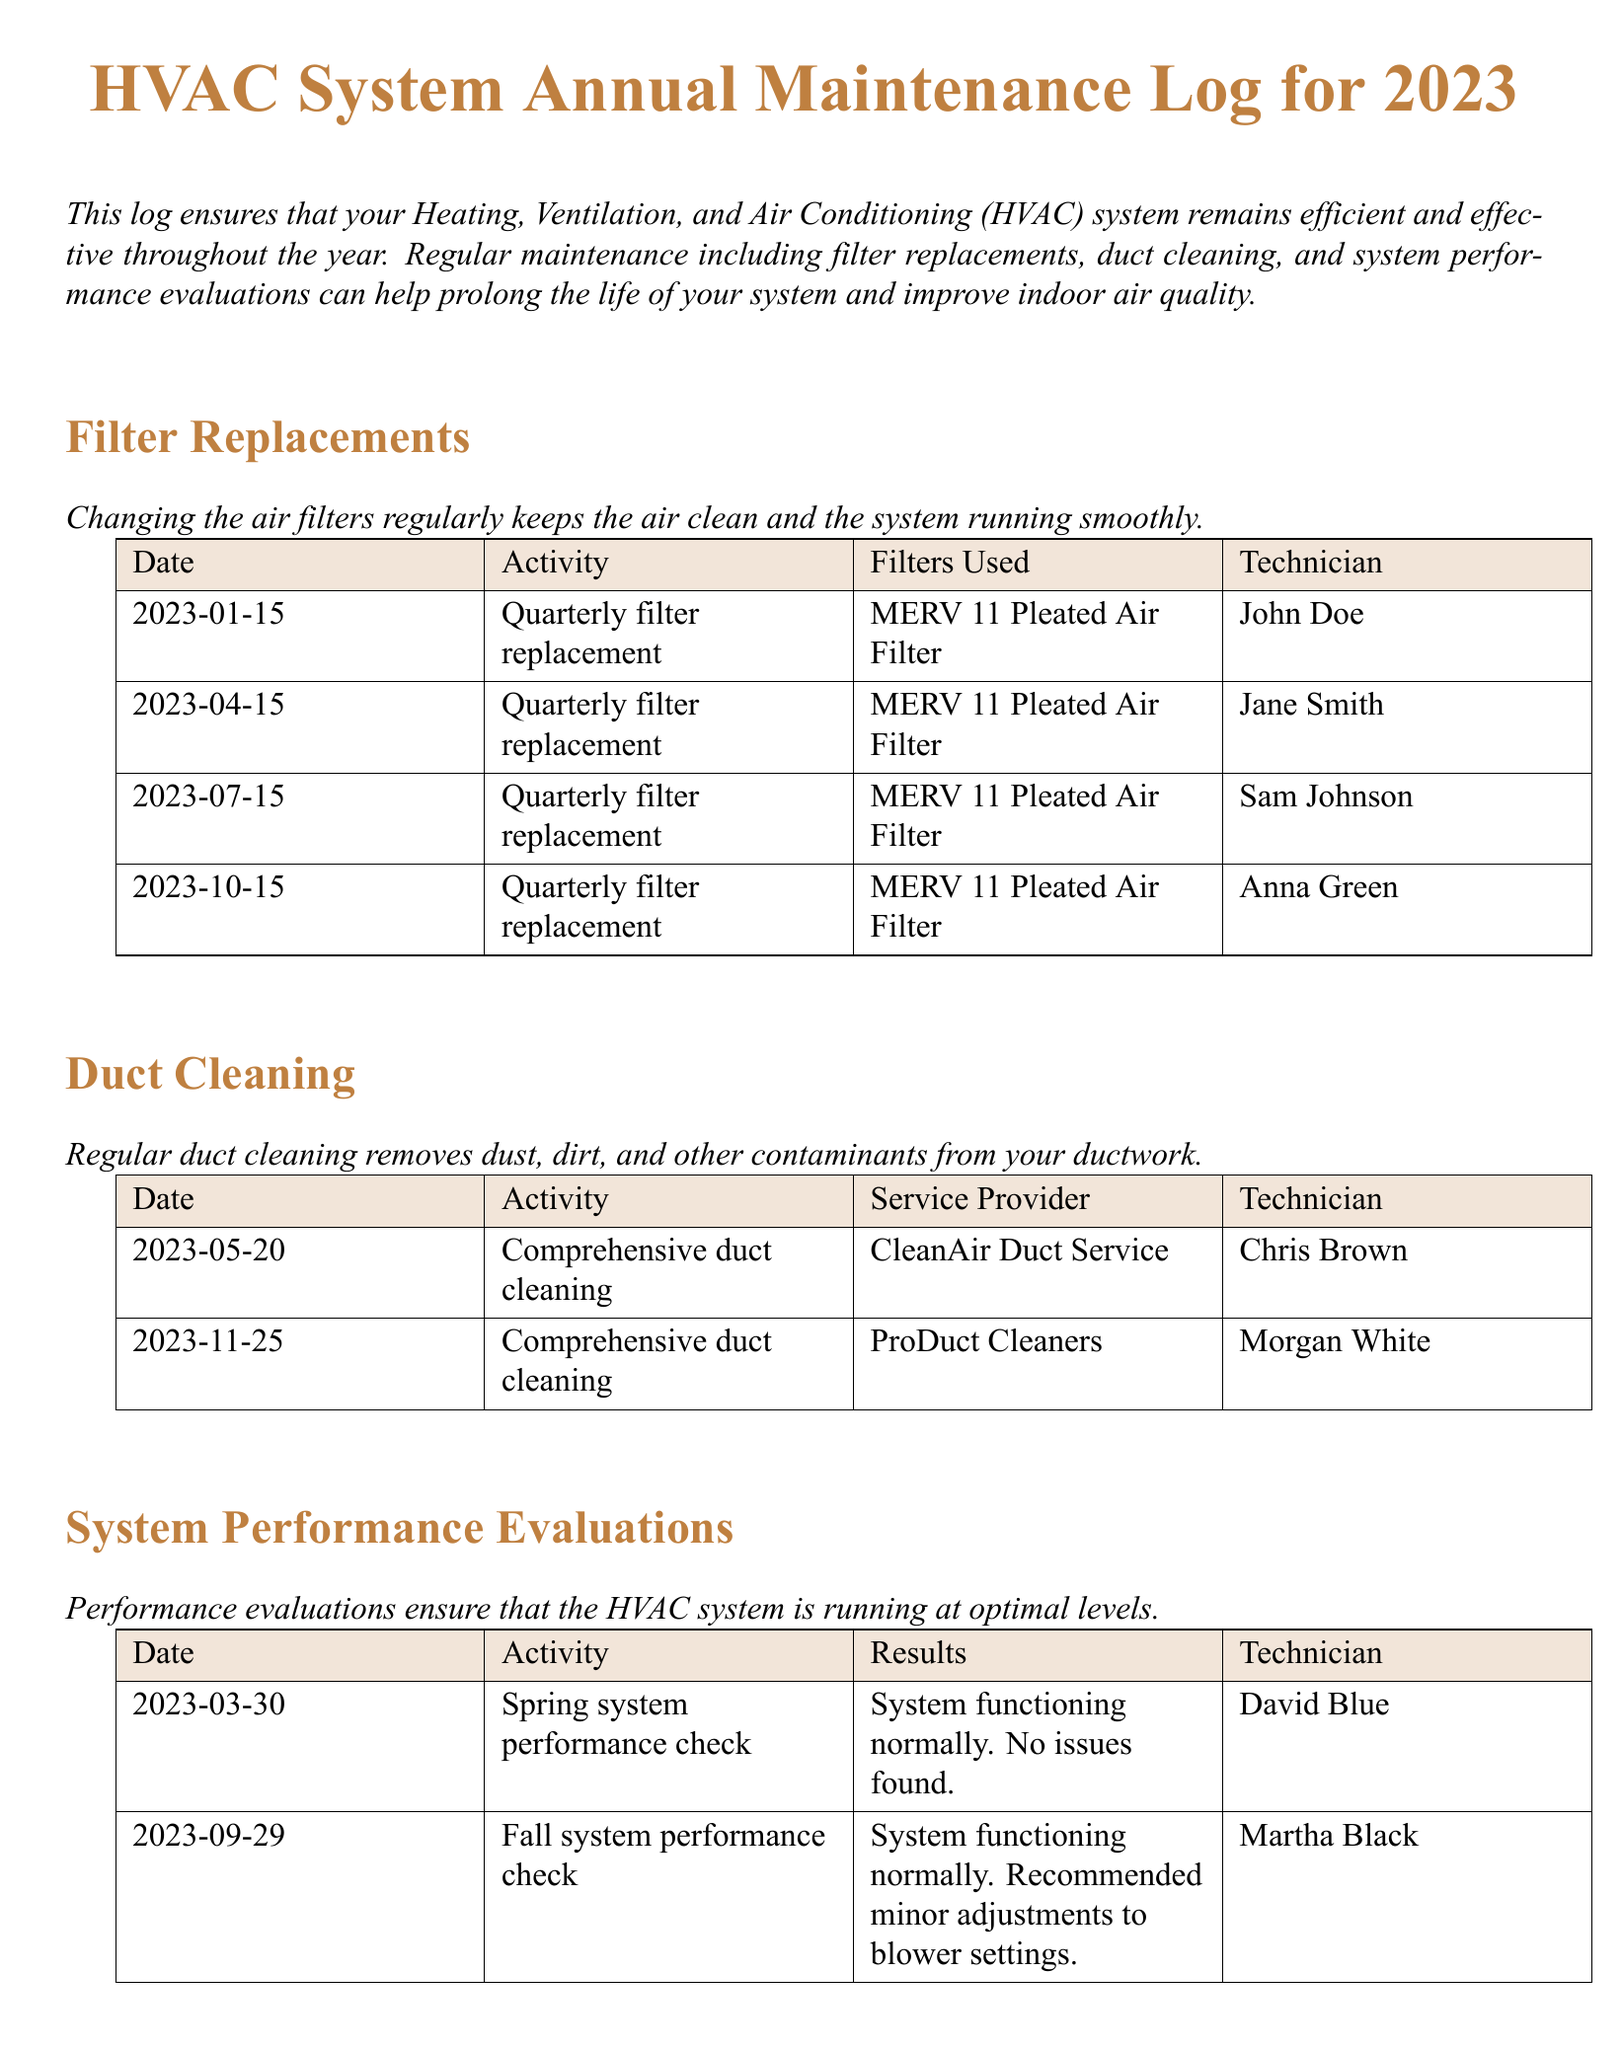What is the purpose of the HVAC System Annual Maintenance Log? The log ensures that your Heating, Ventilation, and Air Conditioning (HVAC) system remains efficient and effective throughout the year.
Answer: Efficiency and effectiveness When was the first quarterly filter replacement in 2023? The first quarterly filter replacement is listed as occurring on January 15, 2023.
Answer: January 15, 2023 Who conducted the duct cleaning on May 20, 2023? The duct cleaning on that date was carried out by CleanAir Duct Service, with Chris Brown as the technician.
Answer: Chris Brown How many filter replacements were performed in 2023? Four filter replacements were conducted in the year, one each quarter.
Answer: Four What was the result of the spring system performance check? The system performance check performed in spring showed the system functioning normally with no issues found.
Answer: Functioning normally. No issues found What company provided duct cleaning services on November 25, 2023? The duct cleaning on that date was done by ProDuct Cleaners.
Answer: ProDuct Cleaners How many technicians were involved in filter replacements? Four different technicians were responsible for the filter replacements throughout the year.
Answer: Four What adjustments were recommended after the fall system performance check? Minor adjustments to blower settings were recommended following the fall check.
Answer: Minor adjustments to blower settings What type of air filter was used in all quarterly replacements? The air filter used for all quarterly replacements was identified as a MERV 11 Pleated Air Filter.
Answer: MERV 11 Pleated Air Filter 